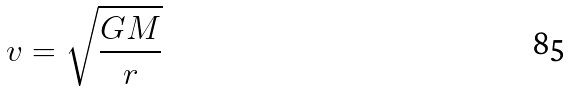Convert formula to latex. <formula><loc_0><loc_0><loc_500><loc_500>v = \sqrt { \frac { G M } { r } }</formula> 